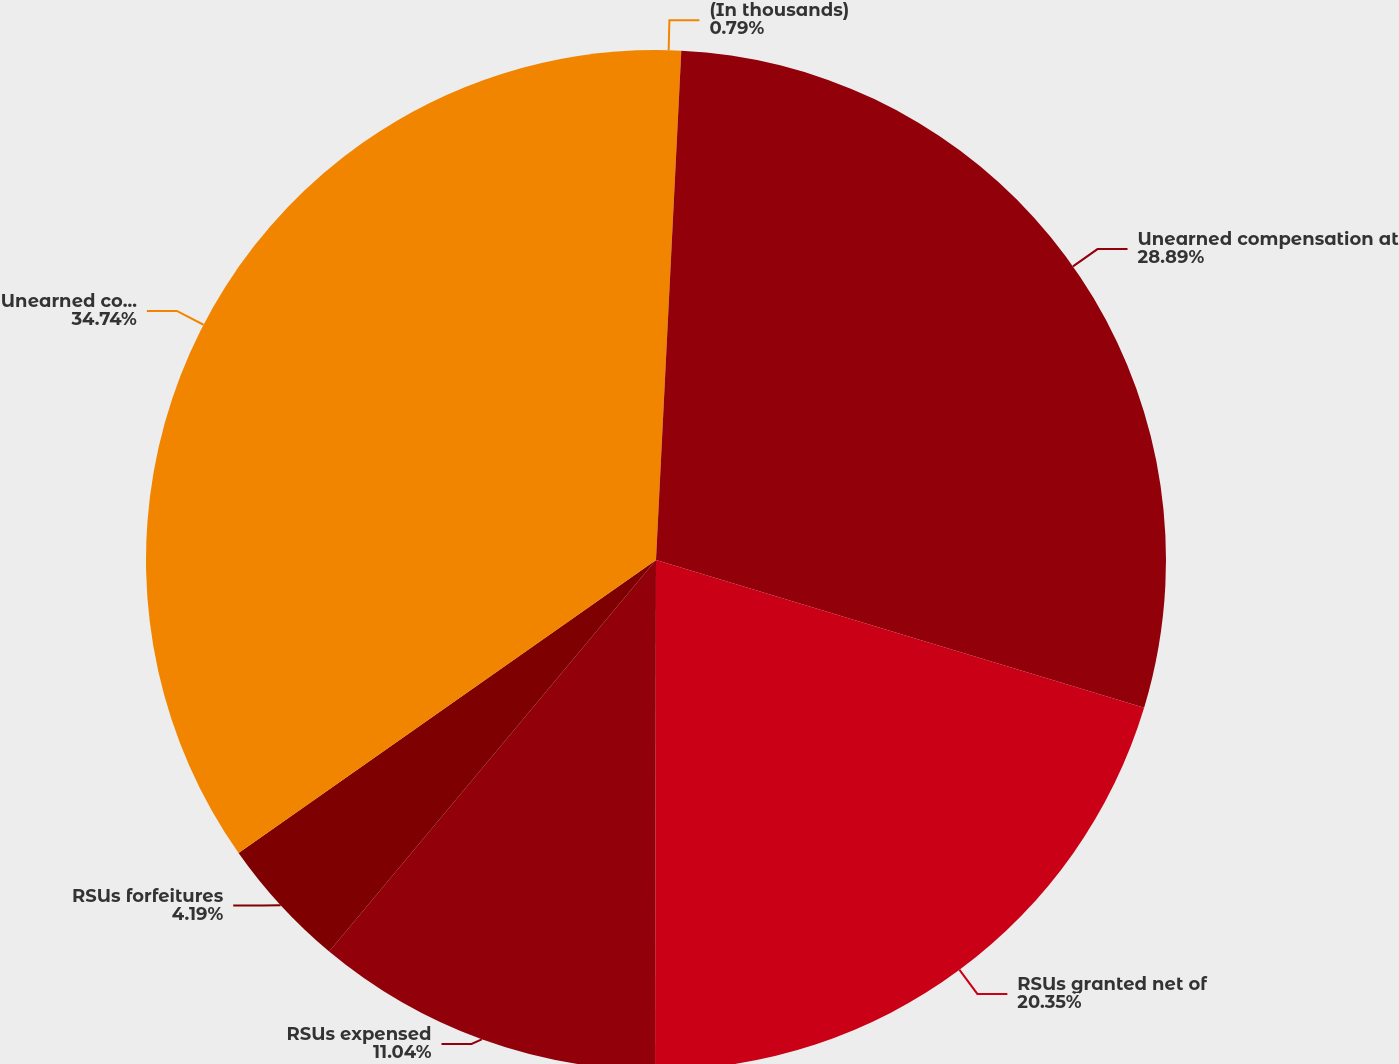Convert chart. <chart><loc_0><loc_0><loc_500><loc_500><pie_chart><fcel>(In thousands)<fcel>Unearned compensation at<fcel>RSUs granted net of<fcel>RSUs expensed<fcel>RSUs forfeitures<fcel>Unearned compensation at end<nl><fcel>0.79%<fcel>28.89%<fcel>20.35%<fcel>11.04%<fcel>4.19%<fcel>34.74%<nl></chart> 